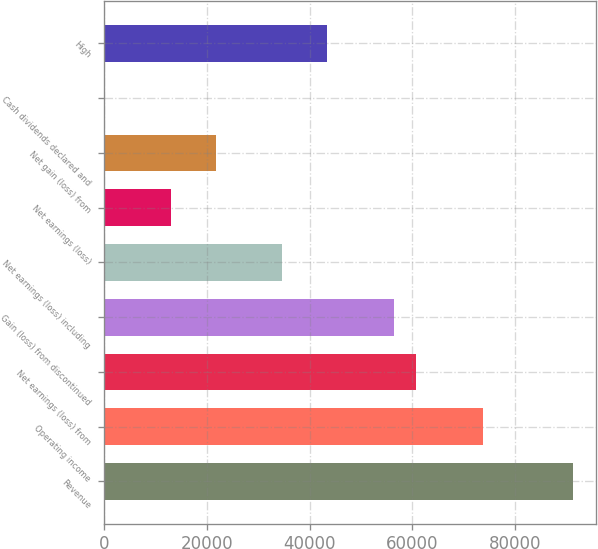<chart> <loc_0><loc_0><loc_500><loc_500><bar_chart><fcel>Revenue<fcel>Operating income<fcel>Net earnings (loss) from<fcel>Gain (loss) from discontinued<fcel>Net earnings (loss) including<fcel>Net earnings (loss)<fcel>Net gain (loss) from<fcel>Cash dividends declared and<fcel>High<nl><fcel>91194<fcel>73823.8<fcel>60796.2<fcel>56453.6<fcel>34740.9<fcel>13028.2<fcel>21713.3<fcel>0.62<fcel>43426<nl></chart> 